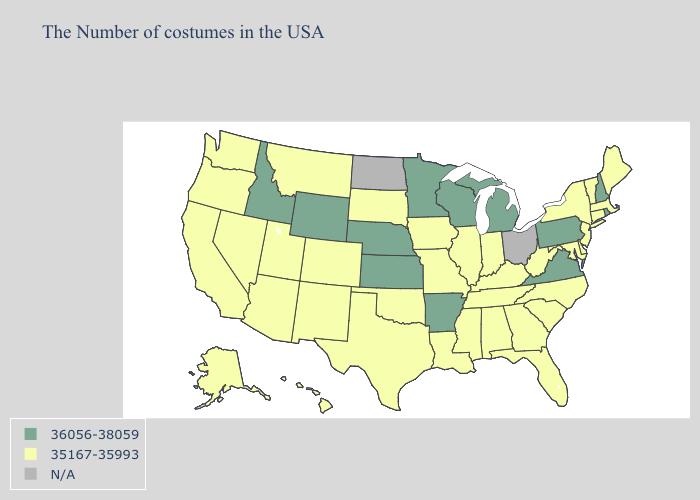What is the lowest value in the USA?
Concise answer only. 35167-35993. What is the lowest value in the South?
Give a very brief answer. 35167-35993. What is the lowest value in the Northeast?
Write a very short answer. 35167-35993. Does Arizona have the lowest value in the West?
Concise answer only. Yes. What is the highest value in the USA?
Answer briefly. 36056-38059. Which states hav the highest value in the Northeast?
Short answer required. Rhode Island, New Hampshire, Pennsylvania. Does the first symbol in the legend represent the smallest category?
Quick response, please. No. Among the states that border New Jersey , does Pennsylvania have the lowest value?
Quick response, please. No. Among the states that border New Hampshire , which have the highest value?
Concise answer only. Maine, Massachusetts, Vermont. Name the states that have a value in the range N/A?
Concise answer only. Ohio, North Dakota. Does Vermont have the highest value in the Northeast?
Be succinct. No. Name the states that have a value in the range N/A?
Give a very brief answer. Ohio, North Dakota. Which states have the lowest value in the South?
Short answer required. Delaware, Maryland, North Carolina, South Carolina, West Virginia, Florida, Georgia, Kentucky, Alabama, Tennessee, Mississippi, Louisiana, Oklahoma, Texas. What is the value of Wisconsin?
Write a very short answer. 36056-38059. 